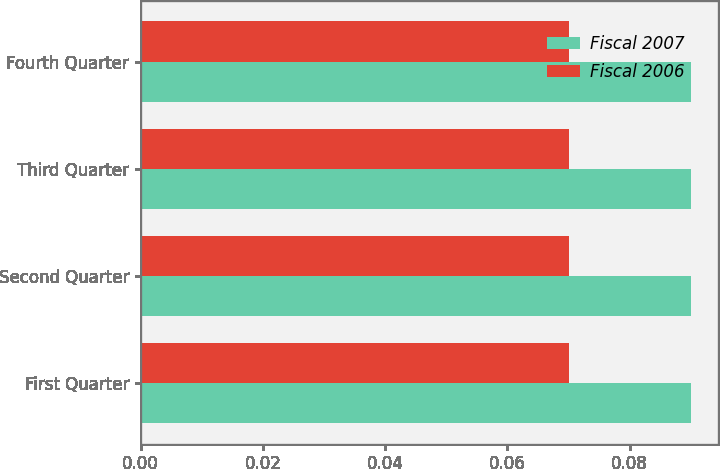Convert chart. <chart><loc_0><loc_0><loc_500><loc_500><stacked_bar_chart><ecel><fcel>First Quarter<fcel>Second Quarter<fcel>Third Quarter<fcel>Fourth Quarter<nl><fcel>Fiscal 2007<fcel>0.09<fcel>0.09<fcel>0.09<fcel>0.09<nl><fcel>Fiscal 2006<fcel>0.07<fcel>0.07<fcel>0.07<fcel>0.07<nl></chart> 